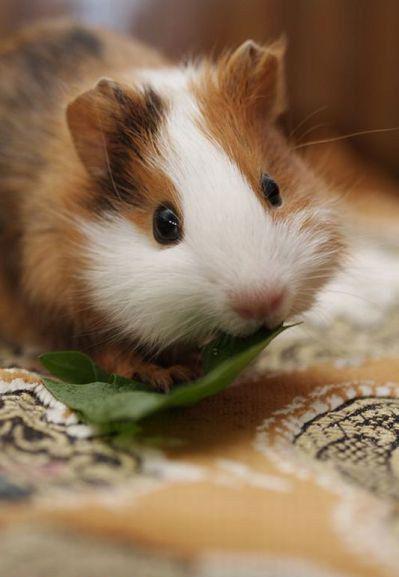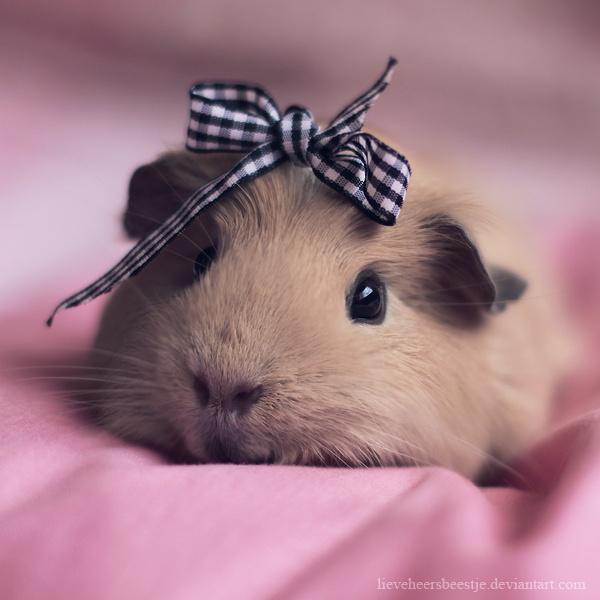The first image is the image on the left, the second image is the image on the right. Given the left and right images, does the statement "One of the images shows only one hamster wearing something on its head." hold true? Answer yes or no. Yes. The first image is the image on the left, the second image is the image on the right. Analyze the images presented: Is the assertion "An image shows just one hamster wearing something decorative on its head." valid? Answer yes or no. Yes. 